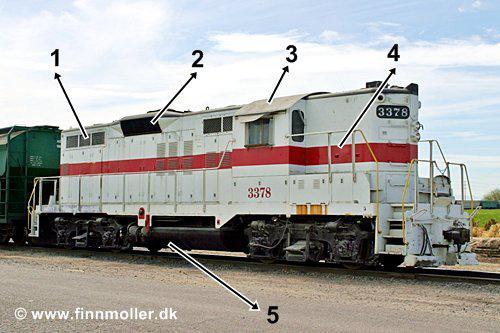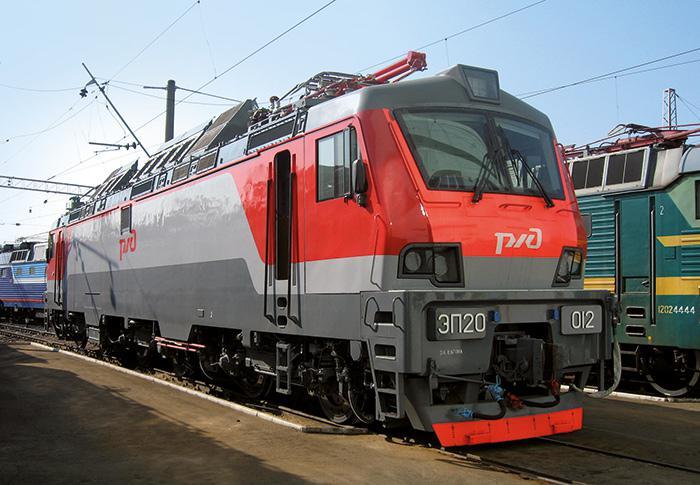The first image is the image on the left, the second image is the image on the right. For the images shown, is this caption "There is absolutely no visible grass in any of the images." true? Answer yes or no. Yes. The first image is the image on the left, the second image is the image on the right. Examine the images to the left and right. Is the description "People wait outside the station to board a red train." accurate? Answer yes or no. No. 